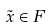Convert formula to latex. <formula><loc_0><loc_0><loc_500><loc_500>\tilde { x } \in F</formula> 